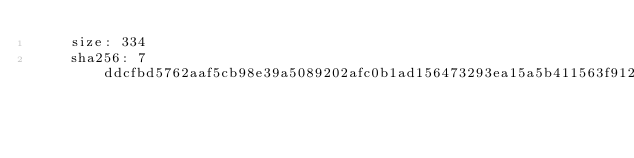Convert code to text. <code><loc_0><loc_0><loc_500><loc_500><_YAML_>    size: 334
    sha256: 7ddcfbd5762aaf5cb98e39a5089202afc0b1ad156473293ea15a5b411563f912</code> 